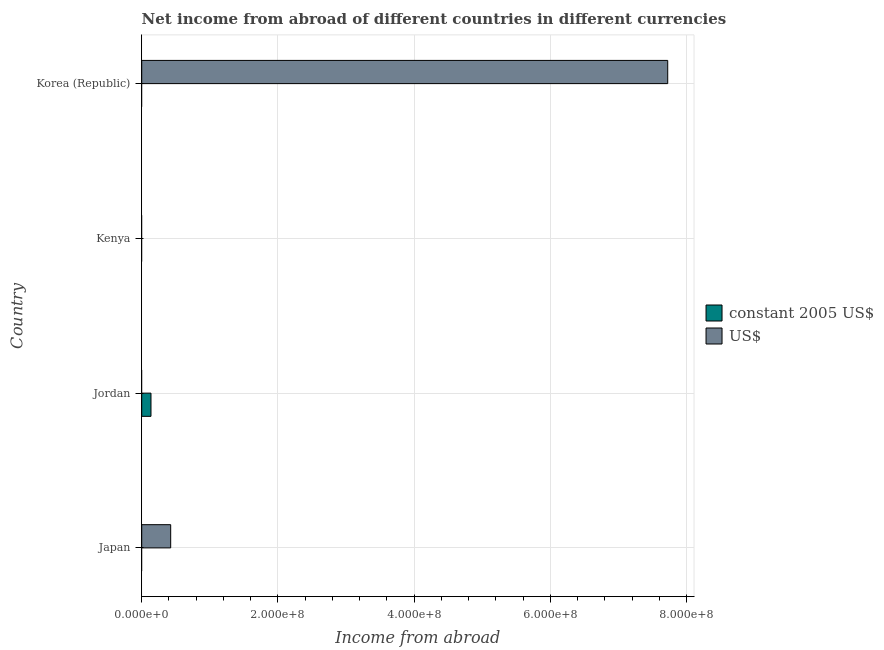Are the number of bars per tick equal to the number of legend labels?
Your answer should be very brief. No. Are the number of bars on each tick of the Y-axis equal?
Make the answer very short. No. How many bars are there on the 2nd tick from the top?
Ensure brevity in your answer.  0. What is the label of the 2nd group of bars from the top?
Offer a very short reply. Kenya. In how many cases, is the number of bars for a given country not equal to the number of legend labels?
Your answer should be very brief. 4. Across all countries, what is the maximum income from abroad in us$?
Provide a succinct answer. 7.72e+08. In which country was the income from abroad in us$ maximum?
Your answer should be very brief. Korea (Republic). What is the total income from abroad in us$ in the graph?
Give a very brief answer. 8.15e+08. What is the difference between the income from abroad in us$ in Japan and that in Korea (Republic)?
Offer a very short reply. -7.30e+08. What is the difference between the income from abroad in us$ in Kenya and the income from abroad in constant 2005 us$ in Jordan?
Your answer should be compact. -1.36e+07. What is the average income from abroad in us$ per country?
Offer a very short reply. 2.04e+08. In how many countries, is the income from abroad in us$ greater than 480000000 units?
Ensure brevity in your answer.  1. What is the difference between the highest and the lowest income from abroad in constant 2005 us$?
Offer a terse response. 1.36e+07. Is the sum of the income from abroad in us$ in Japan and Korea (Republic) greater than the maximum income from abroad in constant 2005 us$ across all countries?
Make the answer very short. Yes. How many countries are there in the graph?
Ensure brevity in your answer.  4. Does the graph contain grids?
Offer a terse response. Yes. Where does the legend appear in the graph?
Offer a terse response. Center right. How are the legend labels stacked?
Ensure brevity in your answer.  Vertical. What is the title of the graph?
Your answer should be compact. Net income from abroad of different countries in different currencies. What is the label or title of the X-axis?
Ensure brevity in your answer.  Income from abroad. What is the Income from abroad in constant 2005 US$ in Japan?
Your answer should be compact. 0. What is the Income from abroad of US$ in Japan?
Provide a short and direct response. 4.25e+07. What is the Income from abroad in constant 2005 US$ in Jordan?
Offer a terse response. 1.36e+07. What is the Income from abroad in constant 2005 US$ in Kenya?
Provide a succinct answer. 0. What is the Income from abroad in US$ in Korea (Republic)?
Your response must be concise. 7.72e+08. Across all countries, what is the maximum Income from abroad in constant 2005 US$?
Make the answer very short. 1.36e+07. Across all countries, what is the maximum Income from abroad of US$?
Your answer should be compact. 7.72e+08. Across all countries, what is the minimum Income from abroad in constant 2005 US$?
Give a very brief answer. 0. Across all countries, what is the minimum Income from abroad of US$?
Your response must be concise. 0. What is the total Income from abroad of constant 2005 US$ in the graph?
Your answer should be very brief. 1.36e+07. What is the total Income from abroad in US$ in the graph?
Give a very brief answer. 8.15e+08. What is the difference between the Income from abroad of US$ in Japan and that in Korea (Republic)?
Offer a terse response. -7.30e+08. What is the difference between the Income from abroad in constant 2005 US$ in Jordan and the Income from abroad in US$ in Korea (Republic)?
Keep it short and to the point. -7.59e+08. What is the average Income from abroad in constant 2005 US$ per country?
Provide a short and direct response. 3.40e+06. What is the average Income from abroad in US$ per country?
Offer a terse response. 2.04e+08. What is the ratio of the Income from abroad of US$ in Japan to that in Korea (Republic)?
Your answer should be very brief. 0.06. What is the difference between the highest and the lowest Income from abroad of constant 2005 US$?
Provide a short and direct response. 1.36e+07. What is the difference between the highest and the lowest Income from abroad of US$?
Provide a short and direct response. 7.72e+08. 